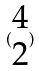Convert formula to latex. <formula><loc_0><loc_0><loc_500><loc_500>( \begin{matrix} 4 \\ 2 \end{matrix} )</formula> 